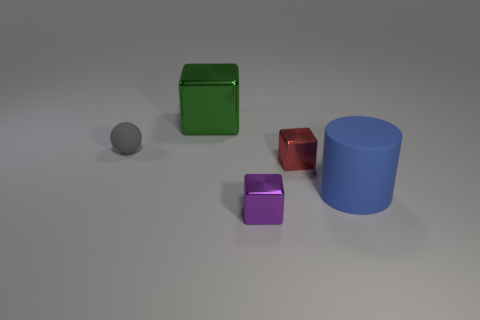Is there another shiny object that has the same shape as the green shiny object?
Make the answer very short. Yes. What color is the other small object that is the same shape as the red shiny object?
Keep it short and to the point. Purple. How big is the rubber object that is behind the big blue object?
Your answer should be compact. Small. There is a matte sphere left of the large metal object; are there any tiny purple objects in front of it?
Keep it short and to the point. Yes. What color is the big cylinder?
Offer a very short reply. Blue. Are there any other things of the same color as the small ball?
Provide a short and direct response. No. What color is the tiny thing that is both behind the tiny purple block and right of the big green shiny cube?
Provide a short and direct response. Red. There is a rubber object right of the green thing; does it have the same size as the green metallic block?
Your answer should be very brief. Yes. Are there more tiny things that are left of the large metal object than small brown cylinders?
Ensure brevity in your answer.  Yes. Does the green metallic thing have the same shape as the red shiny object?
Offer a terse response. Yes. 